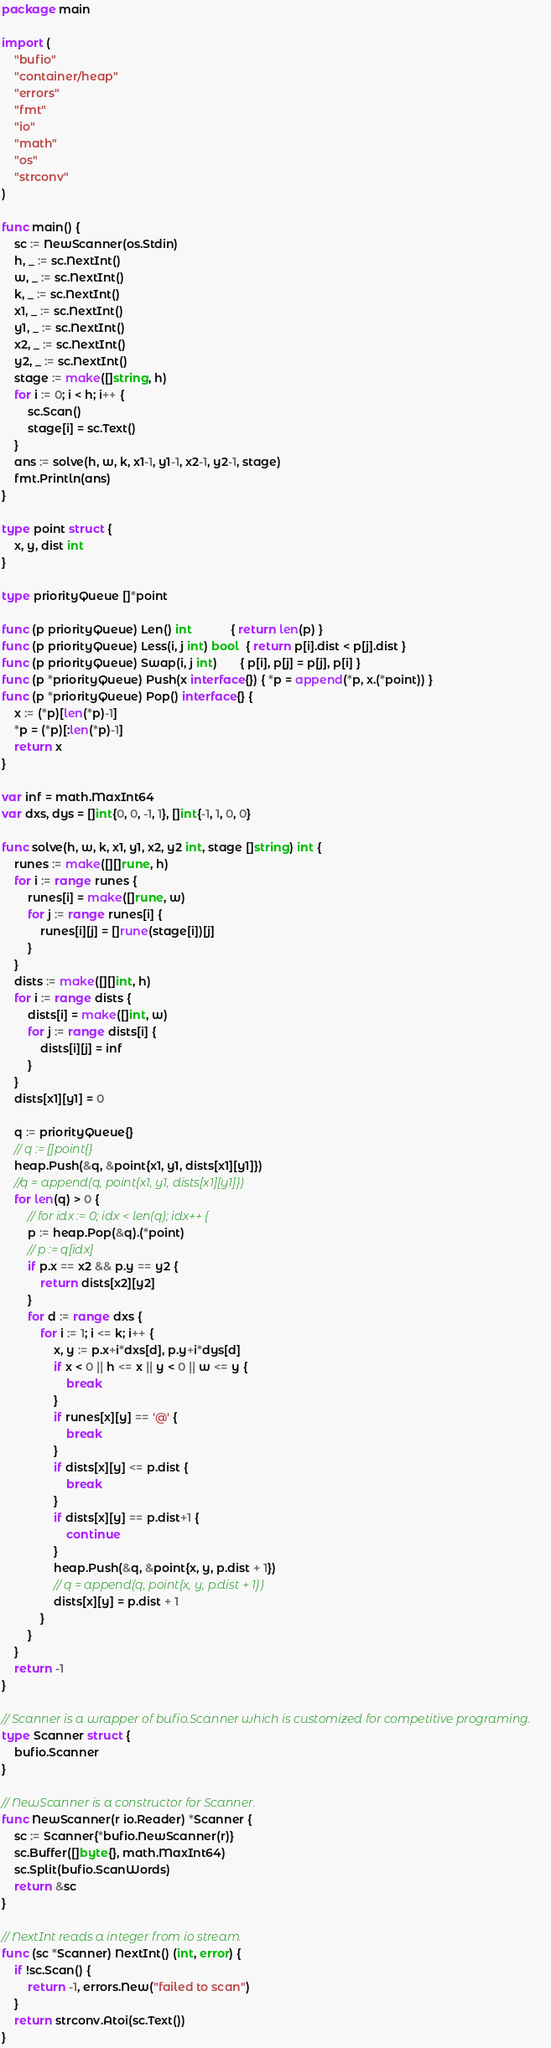Convert code to text. <code><loc_0><loc_0><loc_500><loc_500><_Go_>package main

import (
	"bufio"
	"container/heap"
	"errors"
	"fmt"
	"io"
	"math"
	"os"
	"strconv"
)

func main() {
	sc := NewScanner(os.Stdin)
	h, _ := sc.NextInt()
	w, _ := sc.NextInt()
	k, _ := sc.NextInt()
	x1, _ := sc.NextInt()
	y1, _ := sc.NextInt()
	x2, _ := sc.NextInt()
	y2, _ := sc.NextInt()
	stage := make([]string, h)
	for i := 0; i < h; i++ {
		sc.Scan()
		stage[i] = sc.Text()
	}
	ans := solve(h, w, k, x1-1, y1-1, x2-1, y2-1, stage)
	fmt.Println(ans)
}

type point struct {
	x, y, dist int
}

type priorityQueue []*point

func (p priorityQueue) Len() int            { return len(p) }
func (p priorityQueue) Less(i, j int) bool  { return p[i].dist < p[j].dist }
func (p priorityQueue) Swap(i, j int)       { p[i], p[j] = p[j], p[i] }
func (p *priorityQueue) Push(x interface{}) { *p = append(*p, x.(*point)) }
func (p *priorityQueue) Pop() interface{} {
	x := (*p)[len(*p)-1]
	*p = (*p)[:len(*p)-1]
	return x
}

var inf = math.MaxInt64
var dxs, dys = []int{0, 0, -1, 1}, []int{-1, 1, 0, 0}

func solve(h, w, k, x1, y1, x2, y2 int, stage []string) int {
	runes := make([][]rune, h)
	for i := range runes {
		runes[i] = make([]rune, w)
		for j := range runes[i] {
			runes[i][j] = []rune(stage[i])[j]
		}
	}
	dists := make([][]int, h)
	for i := range dists {
		dists[i] = make([]int, w)
		for j := range dists[i] {
			dists[i][j] = inf
		}
	}
	dists[x1][y1] = 0

	q := priorityQueue{}
	// q := []point{}
	heap.Push(&q, &point{x1, y1, dists[x1][y1]})
	//q = append(q, point{x1, y1, dists[x1][y1]})
	for len(q) > 0 {
		// for idx := 0; idx < len(q); idx++ {
		p := heap.Pop(&q).(*point)
		// p := q[idx]
		if p.x == x2 && p.y == y2 {
			return dists[x2][y2]
		}
		for d := range dxs {
			for i := 1; i <= k; i++ {
				x, y := p.x+i*dxs[d], p.y+i*dys[d]
				if x < 0 || h <= x || y < 0 || w <= y {
					break
				}
				if runes[x][y] == '@' {
					break
				}
				if dists[x][y] <= p.dist {
					break
				}
				if dists[x][y] == p.dist+1 {
					continue
				}
				heap.Push(&q, &point{x, y, p.dist + 1})
				// q = append(q, point{x, y, p.dist + 1})
				dists[x][y] = p.dist + 1
			}
		}
	}
	return -1
}

// Scanner is a wrapper of bufio.Scanner which is customized for competitive programing.
type Scanner struct {
	bufio.Scanner
}

// NewScanner is a constructor for Scanner.
func NewScanner(r io.Reader) *Scanner {
	sc := Scanner{*bufio.NewScanner(r)}
	sc.Buffer([]byte{}, math.MaxInt64)
	sc.Split(bufio.ScanWords)
	return &sc
}

// NextInt reads a integer from io stream.
func (sc *Scanner) NextInt() (int, error) {
	if !sc.Scan() {
		return -1, errors.New("failed to scan")
	}
	return strconv.Atoi(sc.Text())
}
</code> 